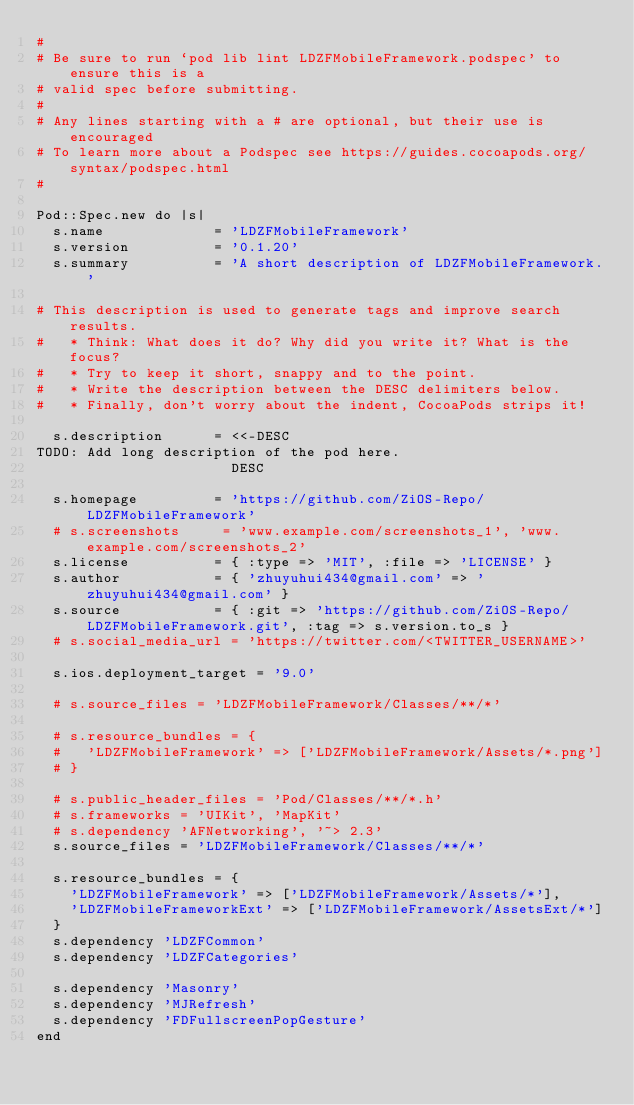<code> <loc_0><loc_0><loc_500><loc_500><_Ruby_>#
# Be sure to run `pod lib lint LDZFMobileFramework.podspec' to ensure this is a
# valid spec before submitting.
#
# Any lines starting with a # are optional, but their use is encouraged
# To learn more about a Podspec see https://guides.cocoapods.org/syntax/podspec.html
#

Pod::Spec.new do |s|
  s.name             = 'LDZFMobileFramework'
  s.version          = '0.1.20'
  s.summary          = 'A short description of LDZFMobileFramework.'
 
# This description is used to generate tags and improve search results.
#   * Think: What does it do? Why did you write it? What is the focus?
#   * Try to keep it short, snappy and to the point.
#   * Write the description between the DESC delimiters below.
#   * Finally, don't worry about the indent, CocoaPods strips it!

  s.description      = <<-DESC
TODO: Add long description of the pod here.
                       DESC

  s.homepage         = 'https://github.com/ZiOS-Repo/LDZFMobileFramework'
  # s.screenshots     = 'www.example.com/screenshots_1', 'www.example.com/screenshots_2'
  s.license          = { :type => 'MIT', :file => 'LICENSE' }
  s.author           = { 'zhuyuhui434@gmail.com' => 'zhuyuhui434@gmail.com' }
  s.source           = { :git => 'https://github.com/ZiOS-Repo/LDZFMobileFramework.git', :tag => s.version.to_s }
  # s.social_media_url = 'https://twitter.com/<TWITTER_USERNAME>'

  s.ios.deployment_target = '9.0'

  # s.source_files = 'LDZFMobileFramework/Classes/**/*'
  
  # s.resource_bundles = {
  #   'LDZFMobileFramework' => ['LDZFMobileFramework/Assets/*.png']
  # }

  # s.public_header_files = 'Pod/Classes/**/*.h'
  # s.frameworks = 'UIKit', 'MapKit'
  # s.dependency 'AFNetworking', '~> 2.3'
  s.source_files = 'LDZFMobileFramework/Classes/**/*'
  
  s.resource_bundles = {
    'LDZFMobileFramework' => ['LDZFMobileFramework/Assets/*'],
    'LDZFMobileFrameworkExt' => ['LDZFMobileFramework/AssetsExt/*']
  }
  s.dependency 'LDZFCommon'
  s.dependency 'LDZFCategories'

  s.dependency 'Masonry'
  s.dependency 'MJRefresh'
  s.dependency 'FDFullscreenPopGesture'
end
</code> 